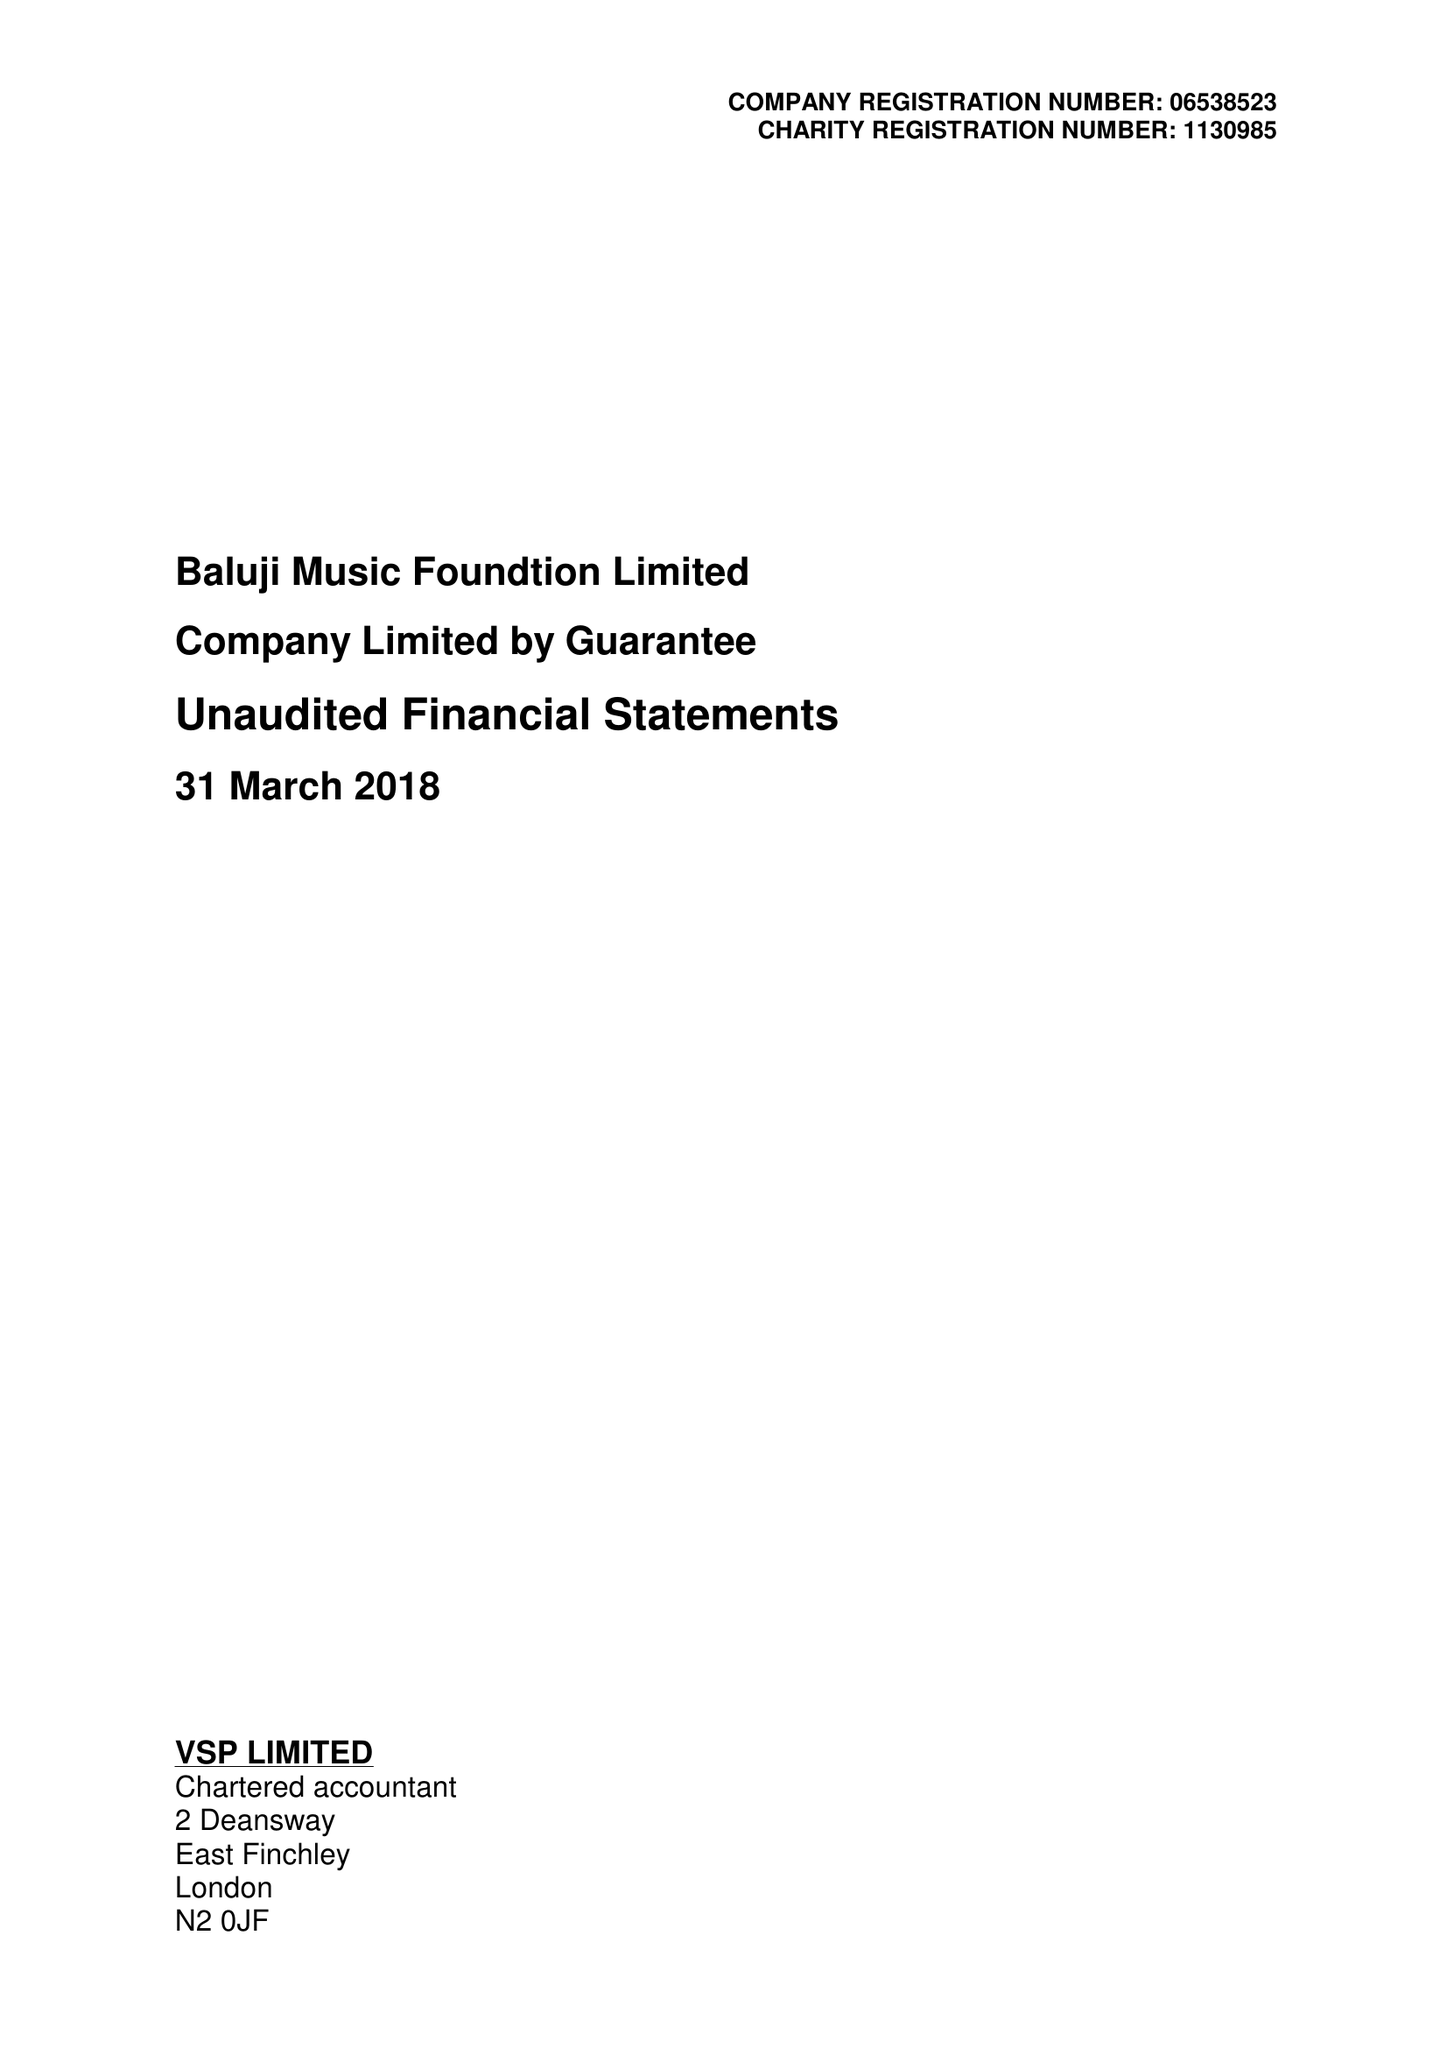What is the value for the spending_annually_in_british_pounds?
Answer the question using a single word or phrase. 46447.00 